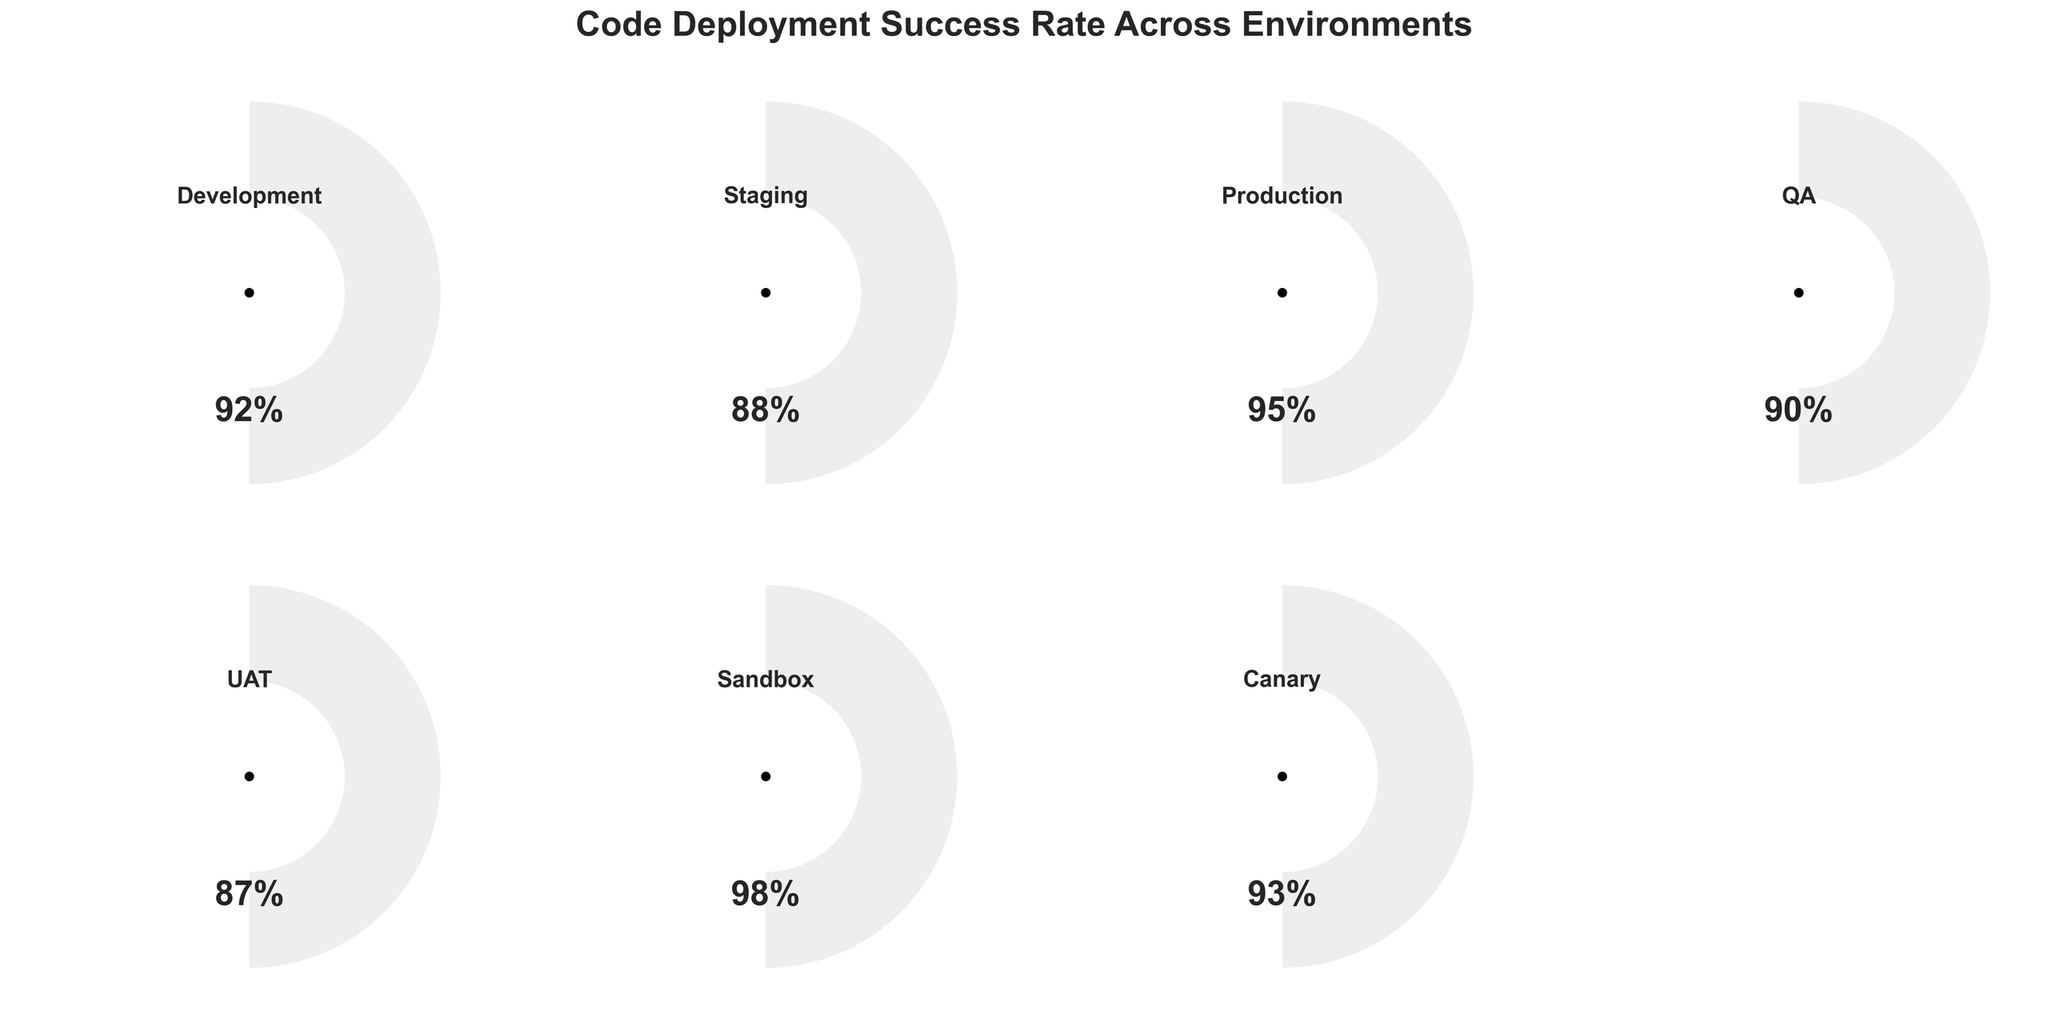What's the title of the figure? The title is usually placed at the top of the figure and gives an overview of what the chart represents.
Answer: Code Deployment Success Rate Across Environments What is the success rate for the Production environment? The Production environment success rate can be found by locating the label "Production" on one of the gauges and reading its corresponding success rate, which is displayed as a percentage.
Answer: 95% Which environment has the highest success rate? To determine the highest success rate, one must compare the success rates of all environments and identify the highest value.
Answer: Sandbox What is the difference in success rate between the UAT and Canary environments? Calculate the success rate difference by subtracting the UAT rate from the Canary rate (93 - 87).
Answer: 6% How many environments have a success rate above 90%? Count the number of environments where the success rate exceeds 90% by examining each gauge.
Answer: 5 What is the average success rate across all environments shown? Sum all the success rates and then divide by the number of environments. (92 + 88 + 95 + 90 + 87 + 98 + 93) / 7 = 643 / 7 ≈ 91.86
Answer: 91.86% Which environment has the lowest success rate? Identify the environment with the smallest success rate by examining and comparing all gauges.
Answer: UAT Are there any environments with an equal success rate? Check for any duplicate success rates among the environments.
Answer: No What's the success rate range in this figure? Calculate the range by subtracting the smallest success rate (87) from the highest success rate (98). 98 - 87 = 11
Answer: 11% What percentage of environments have a success rate between 85% and 95%? Count the number of environments with success rates within this range and divide by the total number of environments, then multiply by 100 for the percentage. (6 environments between 85% and 95% out of 7 total environments) (6/7) * 100 ≈ 85.71%
Answer: 85.71% 